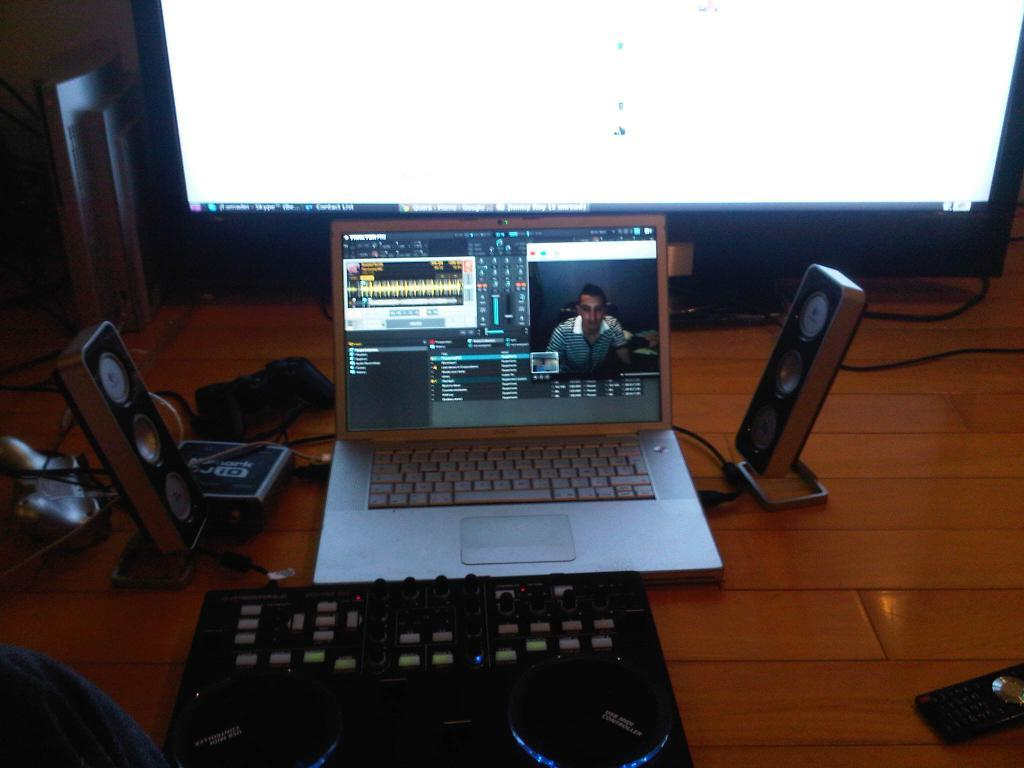What electronic device can be seen in the image? There is a laptop in the image. What else is present in the image besides the laptop? There are wires, a remote, and other objects visible in the image. What is the main object in the middle of the image? A big screen is visible in the middle of the image. What might be used to control the big screen? The remote in the image might be used to control the big screen. What type of degree is being awarded to the vegetable in the image? There is no vegetable present in the image, and therefore no degree can be awarded to it. 